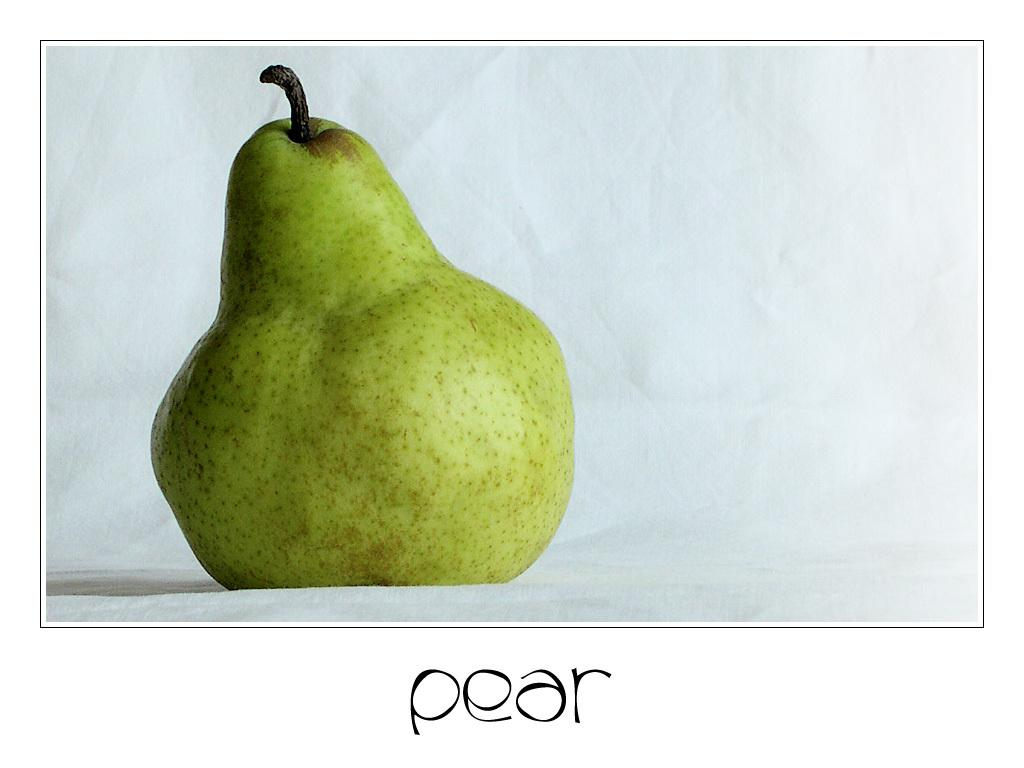What type of fruit is in the image? There is a green pear in the image. What is the color of the surface the pear is on? The pear is on a white surface. Is there any text or writing visible in the image? Yes, there is text or writing visible in the image. How many chickens are standing near the pear in the image? There are no chickens present in the image. What type of sticks are used to hold the pear in the image? There are no sticks present in the image; the pear is simply resting on a white surface. 